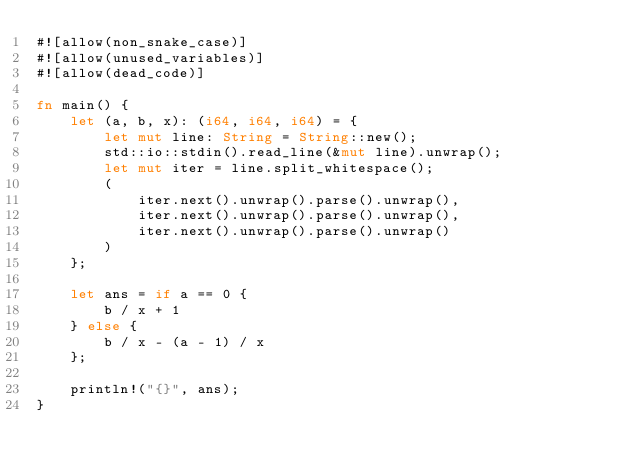<code> <loc_0><loc_0><loc_500><loc_500><_Rust_>#![allow(non_snake_case)]
#![allow(unused_variables)]
#![allow(dead_code)]

fn main() {
    let (a, b, x): (i64, i64, i64) = {
        let mut line: String = String::new();
        std::io::stdin().read_line(&mut line).unwrap();
        let mut iter = line.split_whitespace();
        (
            iter.next().unwrap().parse().unwrap(),
            iter.next().unwrap().parse().unwrap(),
            iter.next().unwrap().parse().unwrap()
        )
    };

    let ans = if a == 0 {
        b / x + 1
    } else {
        b / x - (a - 1) / x
    };

    println!("{}", ans);
}</code> 